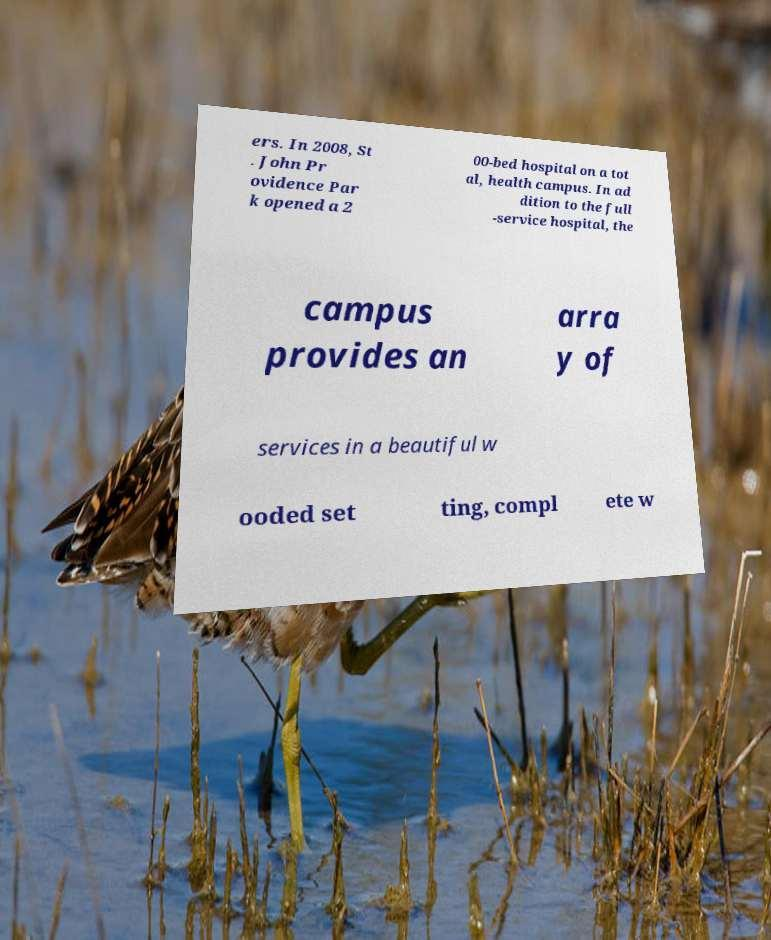Can you read and provide the text displayed in the image?This photo seems to have some interesting text. Can you extract and type it out for me? ers. In 2008, St . John Pr ovidence Par k opened a 2 00-bed hospital on a tot al, health campus. In ad dition to the full -service hospital, the campus provides an arra y of services in a beautiful w ooded set ting, compl ete w 